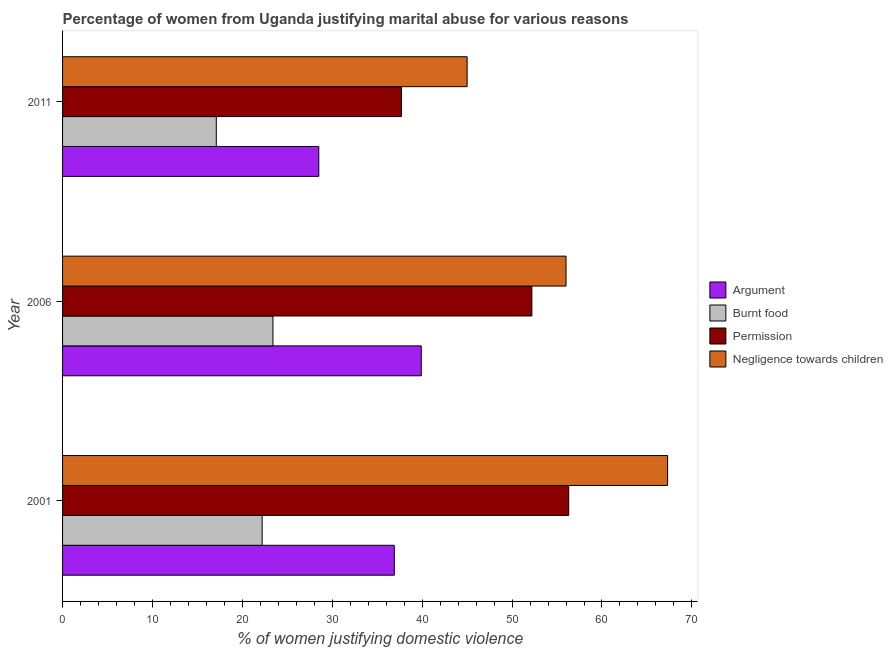How many different coloured bars are there?
Provide a short and direct response. 4. How many groups of bars are there?
Provide a short and direct response. 3. Are the number of bars per tick equal to the number of legend labels?
Offer a terse response. Yes. Are the number of bars on each tick of the Y-axis equal?
Your answer should be compact. Yes. How many bars are there on the 3rd tick from the top?
Ensure brevity in your answer.  4. Across all years, what is the maximum percentage of women justifying abuse for burning food?
Give a very brief answer. 23.4. Across all years, what is the minimum percentage of women justifying abuse for going without permission?
Keep it short and to the point. 37.7. What is the total percentage of women justifying abuse for burning food in the graph?
Offer a very short reply. 62.7. What is the difference between the percentage of women justifying abuse in the case of an argument in 2001 and that in 2006?
Offer a terse response. -3. What is the difference between the percentage of women justifying abuse for going without permission in 2006 and the percentage of women justifying abuse for showing negligence towards children in 2011?
Your answer should be compact. 7.2. What is the average percentage of women justifying abuse for showing negligence towards children per year?
Make the answer very short. 56.1. In the year 2001, what is the difference between the percentage of women justifying abuse in the case of an argument and percentage of women justifying abuse for showing negligence towards children?
Keep it short and to the point. -30.4. In how many years, is the percentage of women justifying abuse for showing negligence towards children greater than 26 %?
Provide a short and direct response. 3. What is the ratio of the percentage of women justifying abuse for showing negligence towards children in 2001 to that in 2011?
Provide a succinct answer. 1.5. Is the percentage of women justifying abuse for going without permission in 2001 less than that in 2006?
Offer a terse response. No. Is the difference between the percentage of women justifying abuse for going without permission in 2001 and 2006 greater than the difference between the percentage of women justifying abuse for burning food in 2001 and 2006?
Your answer should be very brief. Yes. What is the difference between the highest and the second highest percentage of women justifying abuse for showing negligence towards children?
Offer a very short reply. 11.3. What is the difference between the highest and the lowest percentage of women justifying abuse for going without permission?
Provide a succinct answer. 18.6. In how many years, is the percentage of women justifying abuse in the case of an argument greater than the average percentage of women justifying abuse in the case of an argument taken over all years?
Offer a very short reply. 2. What does the 4th bar from the top in 2006 represents?
Offer a terse response. Argument. What does the 1st bar from the bottom in 2011 represents?
Give a very brief answer. Argument. What is the difference between two consecutive major ticks on the X-axis?
Make the answer very short. 10. Are the values on the major ticks of X-axis written in scientific E-notation?
Make the answer very short. No. Where does the legend appear in the graph?
Provide a succinct answer. Center right. How many legend labels are there?
Your answer should be very brief. 4. How are the legend labels stacked?
Make the answer very short. Vertical. What is the title of the graph?
Offer a very short reply. Percentage of women from Uganda justifying marital abuse for various reasons. What is the label or title of the X-axis?
Provide a succinct answer. % of women justifying domestic violence. What is the label or title of the Y-axis?
Keep it short and to the point. Year. What is the % of women justifying domestic violence of Argument in 2001?
Your response must be concise. 36.9. What is the % of women justifying domestic violence of Burnt food in 2001?
Your answer should be compact. 22.2. What is the % of women justifying domestic violence in Permission in 2001?
Keep it short and to the point. 56.3. What is the % of women justifying domestic violence in Negligence towards children in 2001?
Your answer should be compact. 67.3. What is the % of women justifying domestic violence in Argument in 2006?
Give a very brief answer. 39.9. What is the % of women justifying domestic violence in Burnt food in 2006?
Offer a very short reply. 23.4. What is the % of women justifying domestic violence in Permission in 2006?
Provide a short and direct response. 52.2. What is the % of women justifying domestic violence in Argument in 2011?
Provide a succinct answer. 28.5. What is the % of women justifying domestic violence in Permission in 2011?
Provide a short and direct response. 37.7. Across all years, what is the maximum % of women justifying domestic violence of Argument?
Your answer should be very brief. 39.9. Across all years, what is the maximum % of women justifying domestic violence in Burnt food?
Provide a short and direct response. 23.4. Across all years, what is the maximum % of women justifying domestic violence of Permission?
Your answer should be very brief. 56.3. Across all years, what is the maximum % of women justifying domestic violence in Negligence towards children?
Your response must be concise. 67.3. Across all years, what is the minimum % of women justifying domestic violence of Argument?
Ensure brevity in your answer.  28.5. Across all years, what is the minimum % of women justifying domestic violence of Permission?
Your answer should be very brief. 37.7. What is the total % of women justifying domestic violence of Argument in the graph?
Ensure brevity in your answer.  105.3. What is the total % of women justifying domestic violence in Burnt food in the graph?
Provide a short and direct response. 62.7. What is the total % of women justifying domestic violence in Permission in the graph?
Give a very brief answer. 146.2. What is the total % of women justifying domestic violence in Negligence towards children in the graph?
Provide a short and direct response. 168.3. What is the difference between the % of women justifying domestic violence in Negligence towards children in 2001 and that in 2006?
Provide a short and direct response. 11.3. What is the difference between the % of women justifying domestic violence of Burnt food in 2001 and that in 2011?
Provide a succinct answer. 5.1. What is the difference between the % of women justifying domestic violence of Negligence towards children in 2001 and that in 2011?
Make the answer very short. 22.3. What is the difference between the % of women justifying domestic violence of Argument in 2006 and that in 2011?
Ensure brevity in your answer.  11.4. What is the difference between the % of women justifying domestic violence of Permission in 2006 and that in 2011?
Give a very brief answer. 14.5. What is the difference between the % of women justifying domestic violence of Argument in 2001 and the % of women justifying domestic violence of Permission in 2006?
Your answer should be compact. -15.3. What is the difference between the % of women justifying domestic violence of Argument in 2001 and the % of women justifying domestic violence of Negligence towards children in 2006?
Your answer should be very brief. -19.1. What is the difference between the % of women justifying domestic violence in Burnt food in 2001 and the % of women justifying domestic violence in Permission in 2006?
Offer a terse response. -30. What is the difference between the % of women justifying domestic violence in Burnt food in 2001 and the % of women justifying domestic violence in Negligence towards children in 2006?
Provide a succinct answer. -33.8. What is the difference between the % of women justifying domestic violence in Permission in 2001 and the % of women justifying domestic violence in Negligence towards children in 2006?
Offer a very short reply. 0.3. What is the difference between the % of women justifying domestic violence in Argument in 2001 and the % of women justifying domestic violence in Burnt food in 2011?
Provide a short and direct response. 19.8. What is the difference between the % of women justifying domestic violence of Argument in 2001 and the % of women justifying domestic violence of Permission in 2011?
Offer a very short reply. -0.8. What is the difference between the % of women justifying domestic violence in Argument in 2001 and the % of women justifying domestic violence in Negligence towards children in 2011?
Ensure brevity in your answer.  -8.1. What is the difference between the % of women justifying domestic violence in Burnt food in 2001 and the % of women justifying domestic violence in Permission in 2011?
Your response must be concise. -15.5. What is the difference between the % of women justifying domestic violence of Burnt food in 2001 and the % of women justifying domestic violence of Negligence towards children in 2011?
Provide a succinct answer. -22.8. What is the difference between the % of women justifying domestic violence in Argument in 2006 and the % of women justifying domestic violence in Burnt food in 2011?
Your response must be concise. 22.8. What is the difference between the % of women justifying domestic violence in Burnt food in 2006 and the % of women justifying domestic violence in Permission in 2011?
Your answer should be compact. -14.3. What is the difference between the % of women justifying domestic violence in Burnt food in 2006 and the % of women justifying domestic violence in Negligence towards children in 2011?
Your answer should be compact. -21.6. What is the average % of women justifying domestic violence in Argument per year?
Your answer should be very brief. 35.1. What is the average % of women justifying domestic violence of Burnt food per year?
Give a very brief answer. 20.9. What is the average % of women justifying domestic violence in Permission per year?
Provide a succinct answer. 48.73. What is the average % of women justifying domestic violence of Negligence towards children per year?
Make the answer very short. 56.1. In the year 2001, what is the difference between the % of women justifying domestic violence in Argument and % of women justifying domestic violence in Burnt food?
Provide a succinct answer. 14.7. In the year 2001, what is the difference between the % of women justifying domestic violence in Argument and % of women justifying domestic violence in Permission?
Ensure brevity in your answer.  -19.4. In the year 2001, what is the difference between the % of women justifying domestic violence in Argument and % of women justifying domestic violence in Negligence towards children?
Offer a terse response. -30.4. In the year 2001, what is the difference between the % of women justifying domestic violence of Burnt food and % of women justifying domestic violence of Permission?
Give a very brief answer. -34.1. In the year 2001, what is the difference between the % of women justifying domestic violence of Burnt food and % of women justifying domestic violence of Negligence towards children?
Ensure brevity in your answer.  -45.1. In the year 2001, what is the difference between the % of women justifying domestic violence of Permission and % of women justifying domestic violence of Negligence towards children?
Provide a succinct answer. -11. In the year 2006, what is the difference between the % of women justifying domestic violence of Argument and % of women justifying domestic violence of Negligence towards children?
Offer a terse response. -16.1. In the year 2006, what is the difference between the % of women justifying domestic violence in Burnt food and % of women justifying domestic violence in Permission?
Your answer should be compact. -28.8. In the year 2006, what is the difference between the % of women justifying domestic violence in Burnt food and % of women justifying domestic violence in Negligence towards children?
Provide a short and direct response. -32.6. In the year 2011, what is the difference between the % of women justifying domestic violence in Argument and % of women justifying domestic violence in Burnt food?
Provide a short and direct response. 11.4. In the year 2011, what is the difference between the % of women justifying domestic violence of Argument and % of women justifying domestic violence of Negligence towards children?
Give a very brief answer. -16.5. In the year 2011, what is the difference between the % of women justifying domestic violence of Burnt food and % of women justifying domestic violence of Permission?
Give a very brief answer. -20.6. In the year 2011, what is the difference between the % of women justifying domestic violence in Burnt food and % of women justifying domestic violence in Negligence towards children?
Provide a short and direct response. -27.9. What is the ratio of the % of women justifying domestic violence in Argument in 2001 to that in 2006?
Give a very brief answer. 0.92. What is the ratio of the % of women justifying domestic violence of Burnt food in 2001 to that in 2006?
Offer a terse response. 0.95. What is the ratio of the % of women justifying domestic violence in Permission in 2001 to that in 2006?
Give a very brief answer. 1.08. What is the ratio of the % of women justifying domestic violence of Negligence towards children in 2001 to that in 2006?
Your response must be concise. 1.2. What is the ratio of the % of women justifying domestic violence in Argument in 2001 to that in 2011?
Give a very brief answer. 1.29. What is the ratio of the % of women justifying domestic violence of Burnt food in 2001 to that in 2011?
Give a very brief answer. 1.3. What is the ratio of the % of women justifying domestic violence in Permission in 2001 to that in 2011?
Offer a terse response. 1.49. What is the ratio of the % of women justifying domestic violence of Negligence towards children in 2001 to that in 2011?
Keep it short and to the point. 1.5. What is the ratio of the % of women justifying domestic violence in Burnt food in 2006 to that in 2011?
Offer a terse response. 1.37. What is the ratio of the % of women justifying domestic violence in Permission in 2006 to that in 2011?
Provide a succinct answer. 1.38. What is the ratio of the % of women justifying domestic violence of Negligence towards children in 2006 to that in 2011?
Offer a very short reply. 1.24. What is the difference between the highest and the lowest % of women justifying domestic violence in Argument?
Give a very brief answer. 11.4. What is the difference between the highest and the lowest % of women justifying domestic violence in Negligence towards children?
Keep it short and to the point. 22.3. 